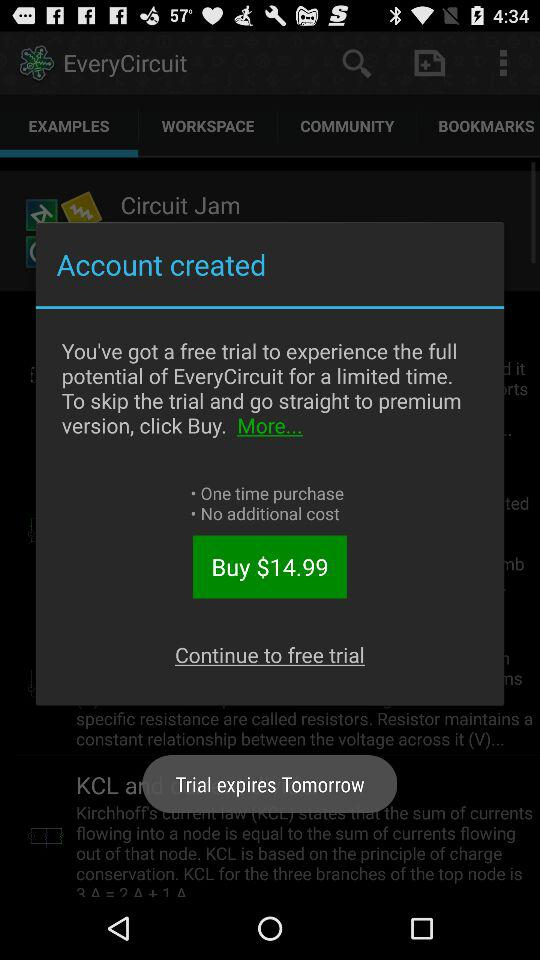When will the trial expire? The trial will expire tomorrow. 